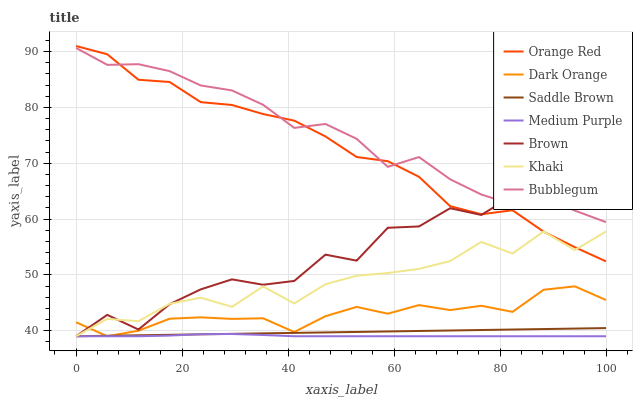Does Medium Purple have the minimum area under the curve?
Answer yes or no. Yes. Does Bubblegum have the maximum area under the curve?
Answer yes or no. Yes. Does Khaki have the minimum area under the curve?
Answer yes or no. No. Does Khaki have the maximum area under the curve?
Answer yes or no. No. Is Saddle Brown the smoothest?
Answer yes or no. Yes. Is Brown the roughest?
Answer yes or no. Yes. Is Khaki the smoothest?
Answer yes or no. No. Is Khaki the roughest?
Answer yes or no. No. Does Dark Orange have the lowest value?
Answer yes or no. Yes. Does Bubblegum have the lowest value?
Answer yes or no. No. Does Orange Red have the highest value?
Answer yes or no. Yes. Does Khaki have the highest value?
Answer yes or no. No. Is Saddle Brown less than Orange Red?
Answer yes or no. Yes. Is Bubblegum greater than Dark Orange?
Answer yes or no. Yes. Does Saddle Brown intersect Medium Purple?
Answer yes or no. Yes. Is Saddle Brown less than Medium Purple?
Answer yes or no. No. Is Saddle Brown greater than Medium Purple?
Answer yes or no. No. Does Saddle Brown intersect Orange Red?
Answer yes or no. No. 